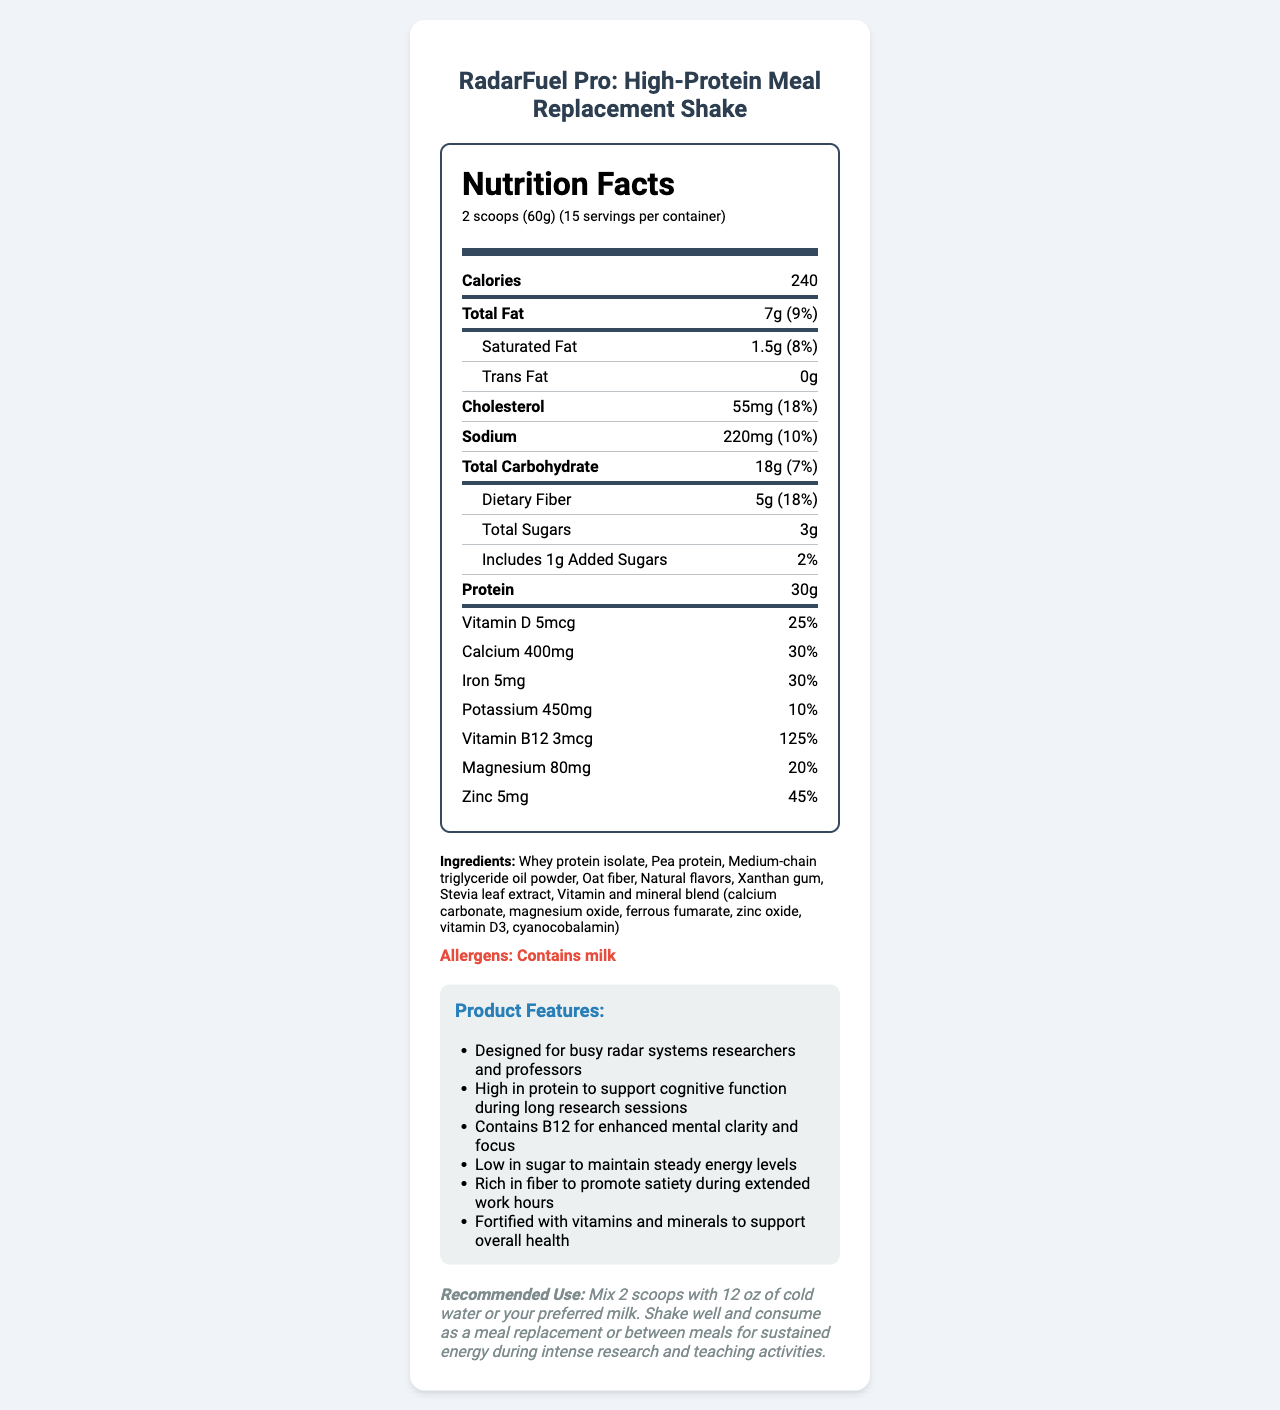what is the serving size? The serving size is explicitly stated as "2 scoops (60g)" at the beginning of the document.
Answer: 2 scoops (60g) how many servings are in a container? The document states there are 15 servings per container.
Answer: 15 how many grams of total fat are in one serving? The nutrition facts list the total fat as "7g".
Answer: 7 grams what is the percentage daily value of sodium in one serving? The sodium daily value percentage is listed as "10%".
Answer: 10% how much protein is there per serving? The document indicates there is 30 grams of protein per serving.
Answer: 30 grams what are the allergens present in the product? The document clearly states that the product contains milk in the allergens section.
Answer: Milk how many calories are in one serving of the shake? The nutrition label lists the calories as "240".
Answer: 240 which of the following vitamins and minerals has the highest percentage daily value? A. Vitamin D B. Calcium C. Iron D. Vitamin B12 The Vitamin B12 has a daily value of "125%", which is the highest among the listed options.
Answer: D. Vitamin B12 what is the total carbohydrate content in one serving? The nutrition facts state the total carbohydrate content as "18g".
Answer: 18 grams which ingredient is listed first in the ingredients list? A. Pea protein B. Xanthan gum C. Whey protein isolate D. Stevia leaf extract The first ingredient listed is "Whey protein isolate".
Answer: C. Whey protein isolate is the shake low in sugar? The shake contains "3g" of total sugars and "1g" of added sugars per serving, which can be considered low.
Answer: Yes describe the product features and recommended use of the RadarFuel Pro shake. This summary encapsulates all the key features and instructions listed in the document.
Answer: The RadarFuel Pro shake is specifically designed for busy researchers and professors, providing high protein to support cognitive function, enriched with Vitamin B12 for mental clarity, low in sugar for steady energy, rich in fiber for satiety, and fortified with essential vitamins and minerals. It is recommended to mix 2 scoops with 12 oz of cold water or preferred milk and consume as a meal replacement or between meals for sustained energy during research and teaching activities. how many different vitamins and minerals are detailed in the nutrition label? The document lists the following vitamins and minerals: Vitamin D, Calcium, Iron, Potassium, Vitamin B12, Magnesium, and Zinc, totaling 7.
Answer: 8 how much dietary fiber is in one serving? The nutrition label specifies that there are 5 grams of dietary fiber per serving.
Answer: 5 grams what is the daily value percentage for calcium per serving, and how does it compare to magnesium? The daily value for calcium is 30% while for magnesium it is 20%, making calcium's daily value percentage higher.
Answer: Calcium: 30%, Magnesium: 20% what does the product claim to support during long research sessions? The product features section mentions that the high protein content supports cognitive function during long research sessions.
Answer: Cognitive function how much cholesterol is in one serving of the shake? The nutrition label lists cholesterol as "55mg".
Answer: 55 mg how many grams of trans fat are present in each serving? The nutrition facts label states that there are 0 grams of trans fat per serving.
Answer: 0 grams what is the unit of measurement for the amount of vitamin B12 in the shake? The label uses micrograms (mcg) as the unit for vitamin B12.
Answer: mcg (micrograms) does the shake contain any artificial sweeteners? The document does not specify whether the natural flavors or stevia leaf extract are considered natural or artificial.
Answer: Cannot be determined which nutrient contributes to the most significant daily value percentage? A. Protein B. Sodium C. Fiber D. Calcium Protein has a daily value percentage of 60%, which is the most significant compared to other nutrients listed.
Answer: A. Protein 